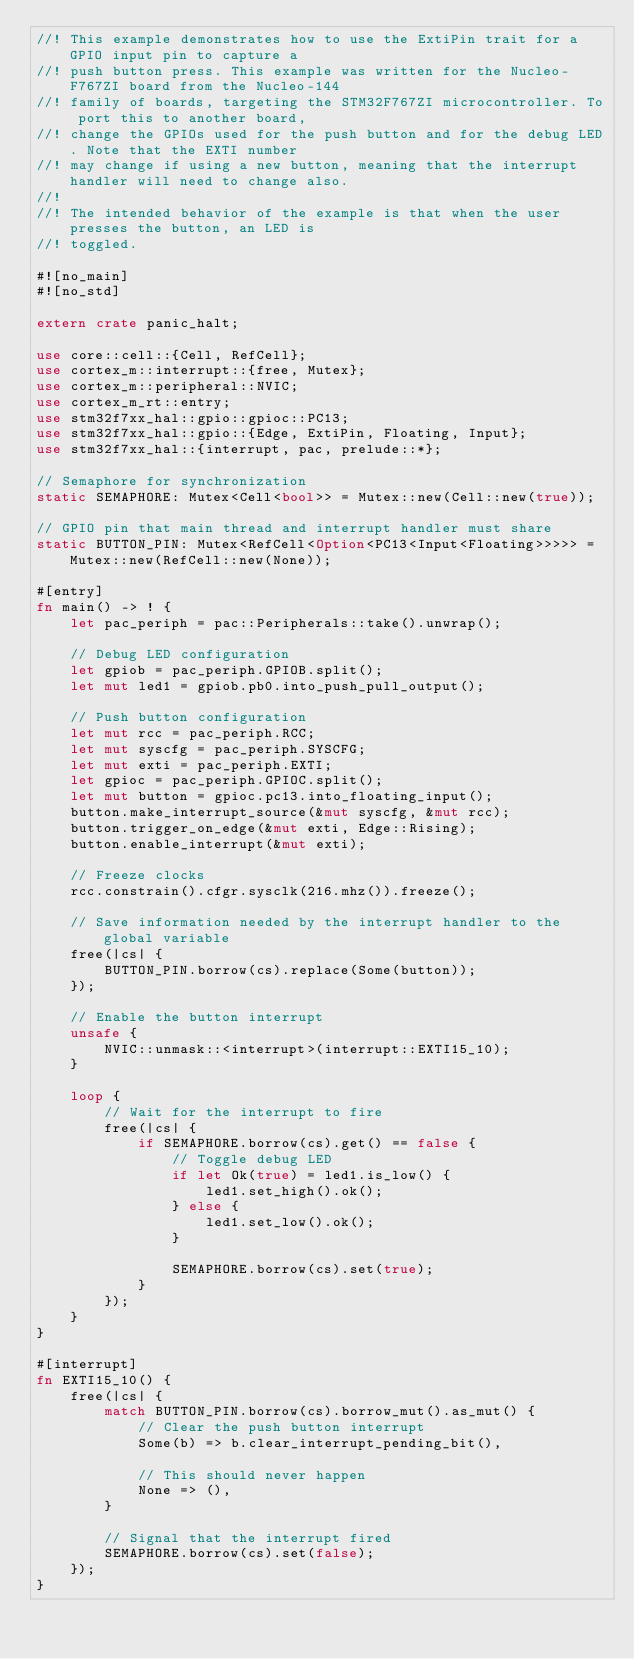Convert code to text. <code><loc_0><loc_0><loc_500><loc_500><_Rust_>//! This example demonstrates how to use the ExtiPin trait for a GPIO input pin to capture a
//! push button press. This example was written for the Nucleo-F767ZI board from the Nucleo-144
//! family of boards, targeting the STM32F767ZI microcontroller. To port this to another board,
//! change the GPIOs used for the push button and for the debug LED. Note that the EXTI number
//! may change if using a new button, meaning that the interrupt handler will need to change also.
//!
//! The intended behavior of the example is that when the user presses the button, an LED is
//! toggled.

#![no_main]
#![no_std]

extern crate panic_halt;

use core::cell::{Cell, RefCell};
use cortex_m::interrupt::{free, Mutex};
use cortex_m::peripheral::NVIC;
use cortex_m_rt::entry;
use stm32f7xx_hal::gpio::gpioc::PC13;
use stm32f7xx_hal::gpio::{Edge, ExtiPin, Floating, Input};
use stm32f7xx_hal::{interrupt, pac, prelude::*};

// Semaphore for synchronization
static SEMAPHORE: Mutex<Cell<bool>> = Mutex::new(Cell::new(true));

// GPIO pin that main thread and interrupt handler must share
static BUTTON_PIN: Mutex<RefCell<Option<PC13<Input<Floating>>>>> = Mutex::new(RefCell::new(None));

#[entry]
fn main() -> ! {
    let pac_periph = pac::Peripherals::take().unwrap();

    // Debug LED configuration
    let gpiob = pac_periph.GPIOB.split();
    let mut led1 = gpiob.pb0.into_push_pull_output();

    // Push button configuration
    let mut rcc = pac_periph.RCC;
    let mut syscfg = pac_periph.SYSCFG;
    let mut exti = pac_periph.EXTI;
    let gpioc = pac_periph.GPIOC.split();
    let mut button = gpioc.pc13.into_floating_input();
    button.make_interrupt_source(&mut syscfg, &mut rcc);
    button.trigger_on_edge(&mut exti, Edge::Rising);
    button.enable_interrupt(&mut exti);

    // Freeze clocks
    rcc.constrain().cfgr.sysclk(216.mhz()).freeze();

    // Save information needed by the interrupt handler to the global variable
    free(|cs| {
        BUTTON_PIN.borrow(cs).replace(Some(button));
    });

    // Enable the button interrupt
    unsafe {
        NVIC::unmask::<interrupt>(interrupt::EXTI15_10);
    }

    loop {
        // Wait for the interrupt to fire
        free(|cs| {
            if SEMAPHORE.borrow(cs).get() == false {
                // Toggle debug LED
                if let Ok(true) = led1.is_low() {
                    led1.set_high().ok();
                } else {
                    led1.set_low().ok();
                }

                SEMAPHORE.borrow(cs).set(true);
            }
        });
    }
}

#[interrupt]
fn EXTI15_10() {
    free(|cs| {
        match BUTTON_PIN.borrow(cs).borrow_mut().as_mut() {
            // Clear the push button interrupt
            Some(b) => b.clear_interrupt_pending_bit(),

            // This should never happen
            None => (),
        }

        // Signal that the interrupt fired
        SEMAPHORE.borrow(cs).set(false);
    });
}
</code> 